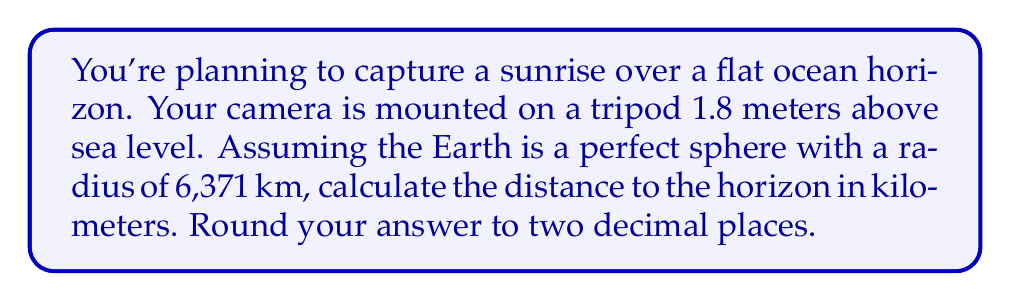Can you answer this question? To solve this problem, we'll use the formula for the distance to the horizon, which is derived from the Pythagorean theorem:

$$d = \sqrt{2Rh + h^2}$$

Where:
$d$ = distance to the horizon
$R$ = radius of the Earth
$h$ = height of the observer (in this case, the camera)

Steps:
1) Convert all measurements to kilometers:
   $R = 6371$ km
   $h = 1.8$ m = $0.0018$ km

2) Substitute these values into the formula:
   $$d = \sqrt{2 \cdot 6371 \cdot 0.0018 + 0.0018^2}$$

3) Simplify inside the square root:
   $$d = \sqrt{22.9356 + 0.00000324}$$
   $$d = \sqrt{22.93560324}$$

4) Calculate the square root:
   $$d \approx 4.7891$$ km

5) Round to two decimal places:
   $$d \approx 4.79$$ km

[asy]
import geometry;

unitsize(1cm);

real R = 6;
real h = 0.2;
real d = sqrt(2*R*h + h^2);

path earth = arc((0,0), R, 180, 360);
draw(earth);

draw((0,R)--(d,R+h), blue);
draw((0,0)--(d,R+h), red);
draw((0,0)--(0,R+h), green);

label("R", (0,R/2), W);
label("h", (0,R+h/2), W);
label("d", (d/2,R+h/2), N);

dot((0,R+h));
label("Camera", (0,R+h), NE);
label("Horizon", (d,R+h), E);
label("Earth's center", (0,0), SW);
[/asy]
Answer: 4.79 km 